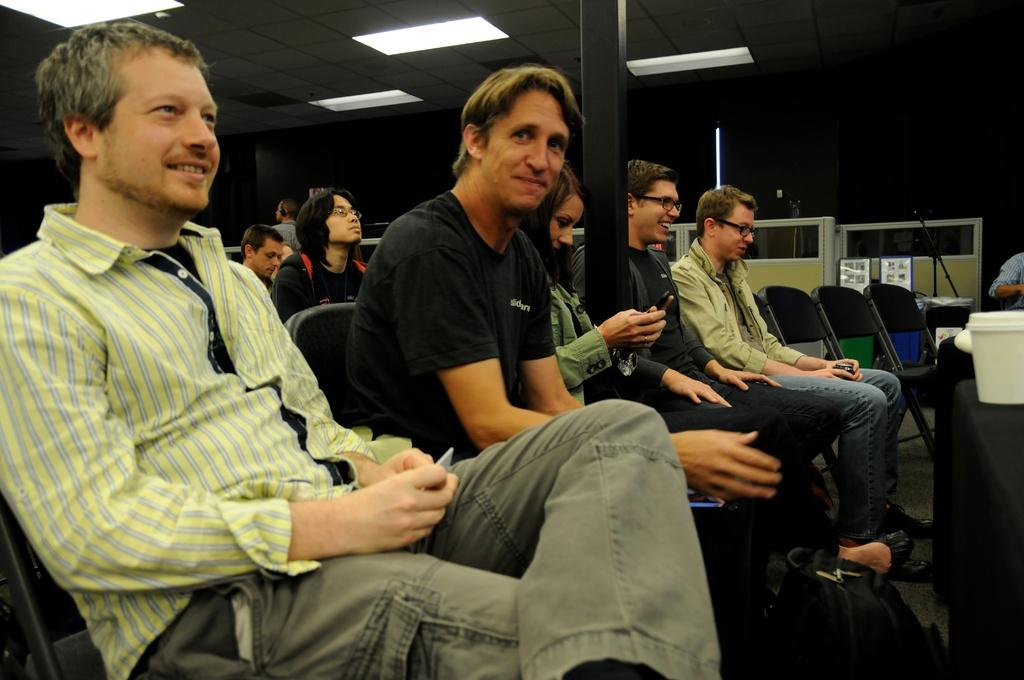What can be seen in the foreground of the image? There are people sitting in the foreground of the image. What is visible in the background of the image? There are lamps and other objects in the background of the image. What type of furniture is present in the background of the image? There are chairs in the background of the image. What direction are the people facing in the image? The provided facts do not mention the direction the people are facing, so it cannot be determined from the image. What are the people reading in the image? There is no indication in the image that the people are reading anything. How much noise can be heard in the image? The provided facts do not mention any sounds or noise levels in the image. 